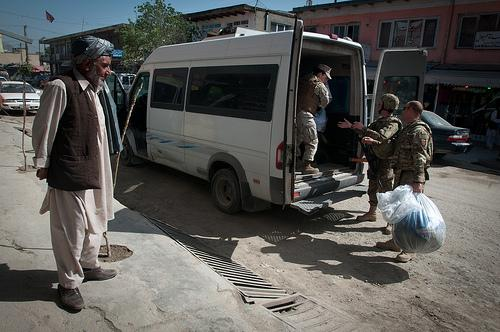Question: who is in this picture?
Choices:
A. Women.
B. Kids.
C. Men.
D. Preachers.
Answer with the letter. Answer: C Question: where is the curb?
Choices:
A. On the corner.
B. Down the street.
C. By the fire hydrant.
D. Beside the van.
Answer with the letter. Answer: D Question: how many windows does the van have?
Choices:
A. Three.
B. Four.
C. Two.
D. Five.
Answer with the letter. Answer: C Question: how does the weather look?
Choices:
A. Cloudy.
B. Rainy.
C. Stormy.
D. Sunny.
Answer with the letter. Answer: D 